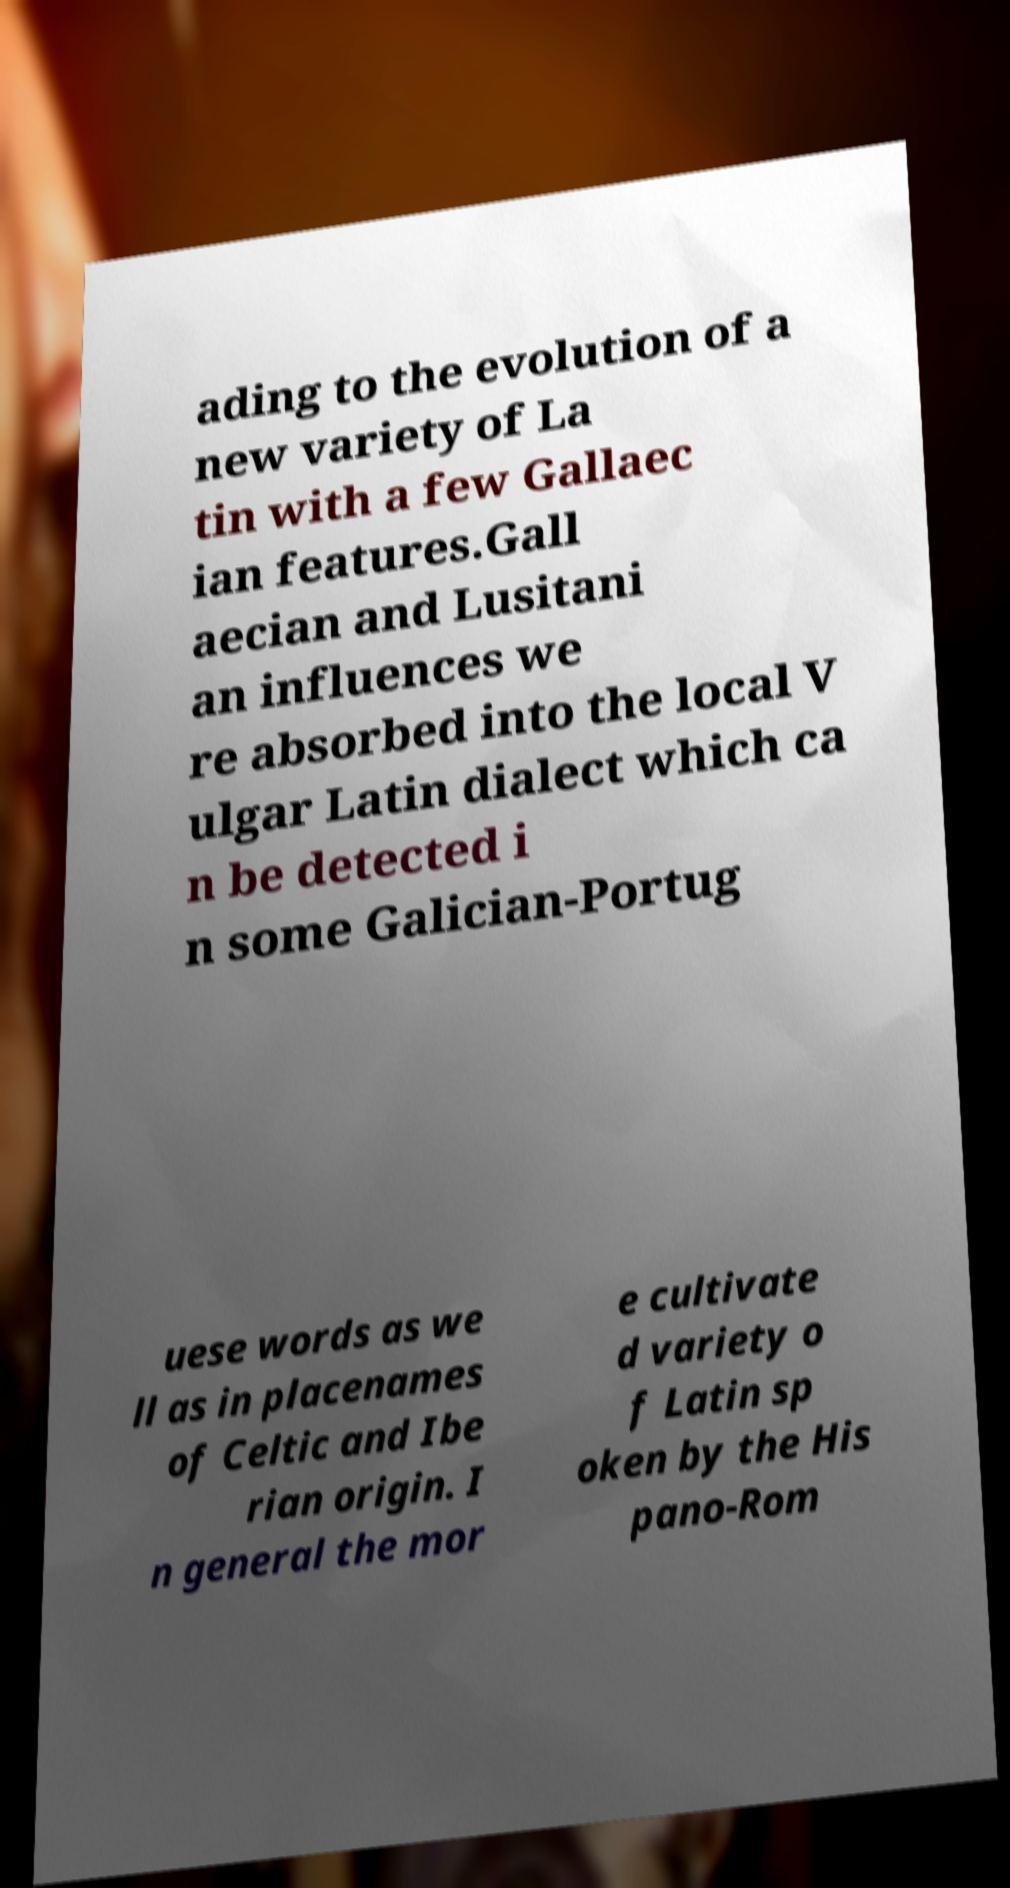Could you extract and type out the text from this image? ading to the evolution of a new variety of La tin with a few Gallaec ian features.Gall aecian and Lusitani an influences we re absorbed into the local V ulgar Latin dialect which ca n be detected i n some Galician-Portug uese words as we ll as in placenames of Celtic and Ibe rian origin. I n general the mor e cultivate d variety o f Latin sp oken by the His pano-Rom 